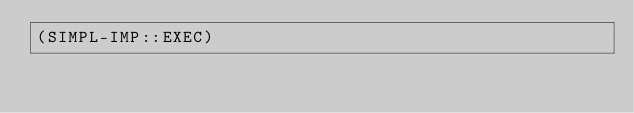Convert code to text. <code><loc_0><loc_0><loc_500><loc_500><_Lisp_>(SIMPL-IMP::EXEC)
</code> 